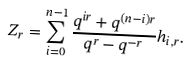Convert formula to latex. <formula><loc_0><loc_0><loc_500><loc_500>Z _ { r } = \sum _ { i = 0 } ^ { n - 1 } \frac { q ^ { i r } + q ^ { ( n - i ) r } } { q ^ { r } - q ^ { - r } } h _ { i , r } .</formula> 